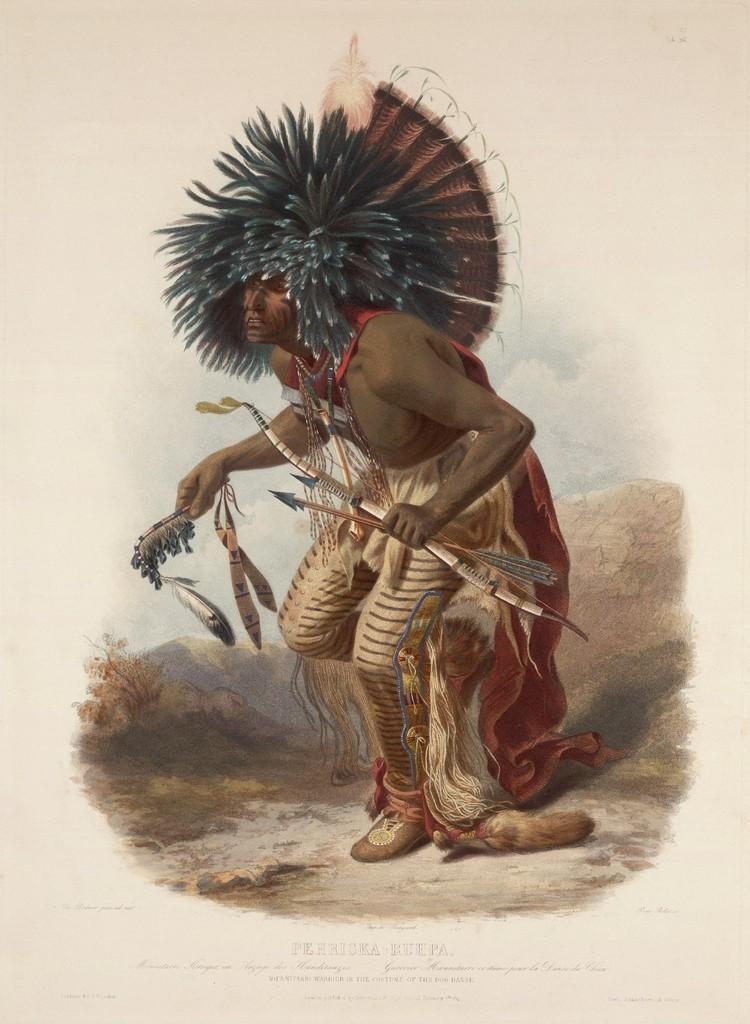Can you describe this image briefly? This is the picture of the painting. In this picture, we see a man is standing and he is holding a bow and arrows in his hand. Behind him, we see hills and trees. In the background, it is white in color and this might be a paper. 